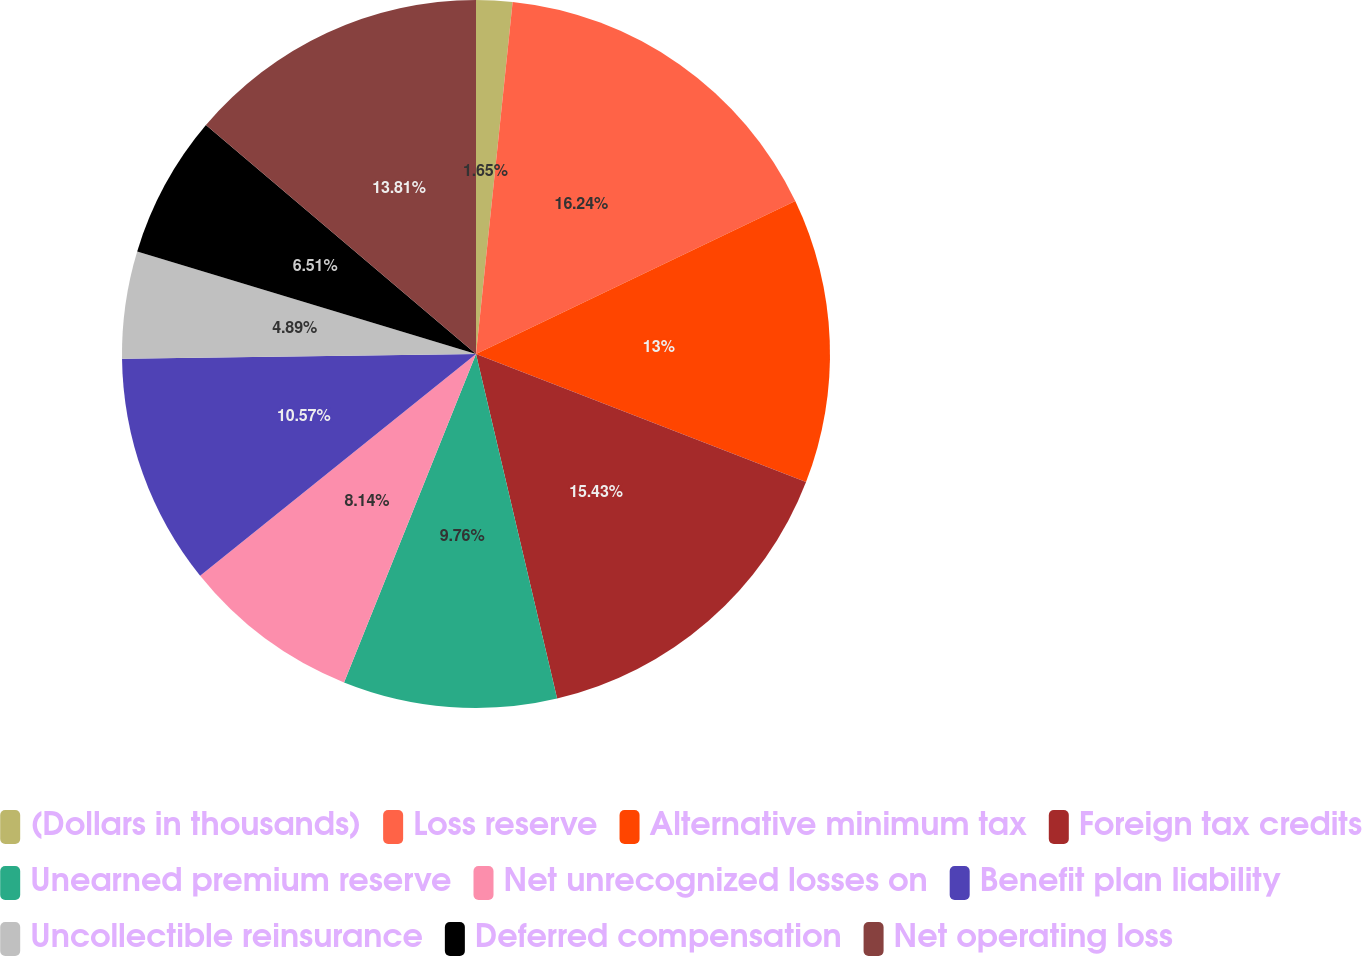Convert chart. <chart><loc_0><loc_0><loc_500><loc_500><pie_chart><fcel>(Dollars in thousands)<fcel>Loss reserve<fcel>Alternative minimum tax<fcel>Foreign tax credits<fcel>Unearned premium reserve<fcel>Net unrecognized losses on<fcel>Benefit plan liability<fcel>Uncollectible reinsurance<fcel>Deferred compensation<fcel>Net operating loss<nl><fcel>1.65%<fcel>16.24%<fcel>13.0%<fcel>15.43%<fcel>9.76%<fcel>8.14%<fcel>10.57%<fcel>4.89%<fcel>6.51%<fcel>13.81%<nl></chart> 